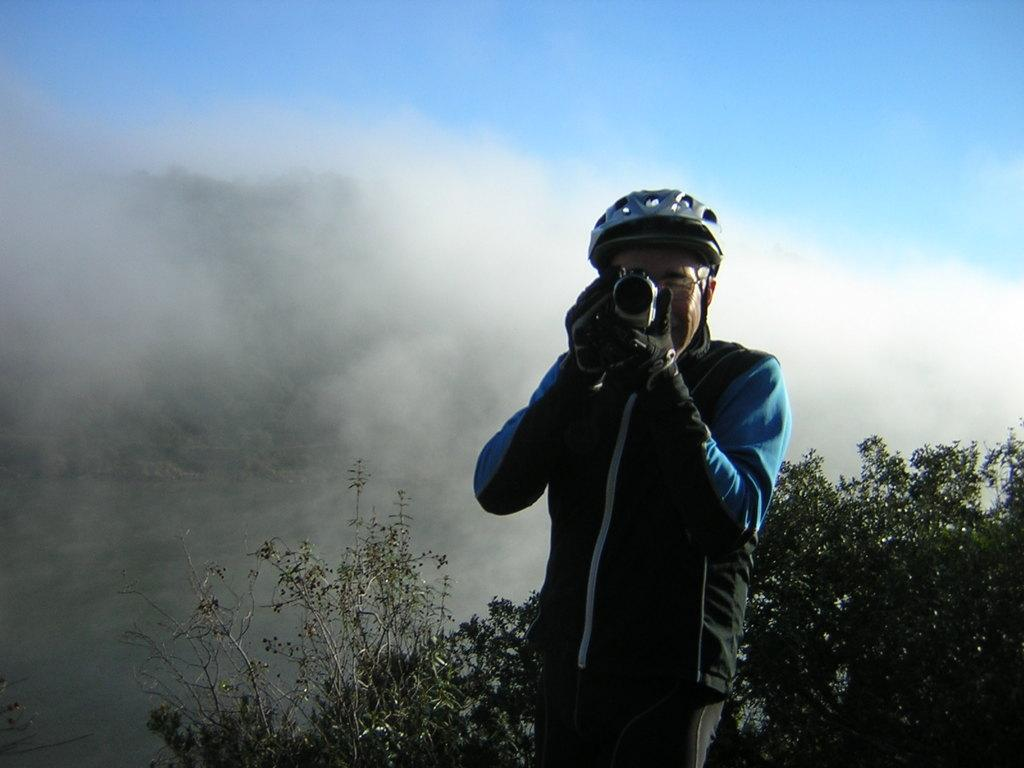What is the main subject of the image? The main subject of the image is a man. Can you describe the man's attire? The man is wearing clothes, spectacles, and a helmet. What is the man holding in his hands? The man is holding a camera in his hands. What can be seen in the background of the image? There are plants visible in the image, and the sky appears to be foggy. What type of ring can be seen on the man's finger in the image? There is no ring visible on the man's finger in the image. How does the stranger feel about the man's photography skills in the image? There is no stranger present in the image, so it is not possible to determine their feelings about the man's photography skills. 